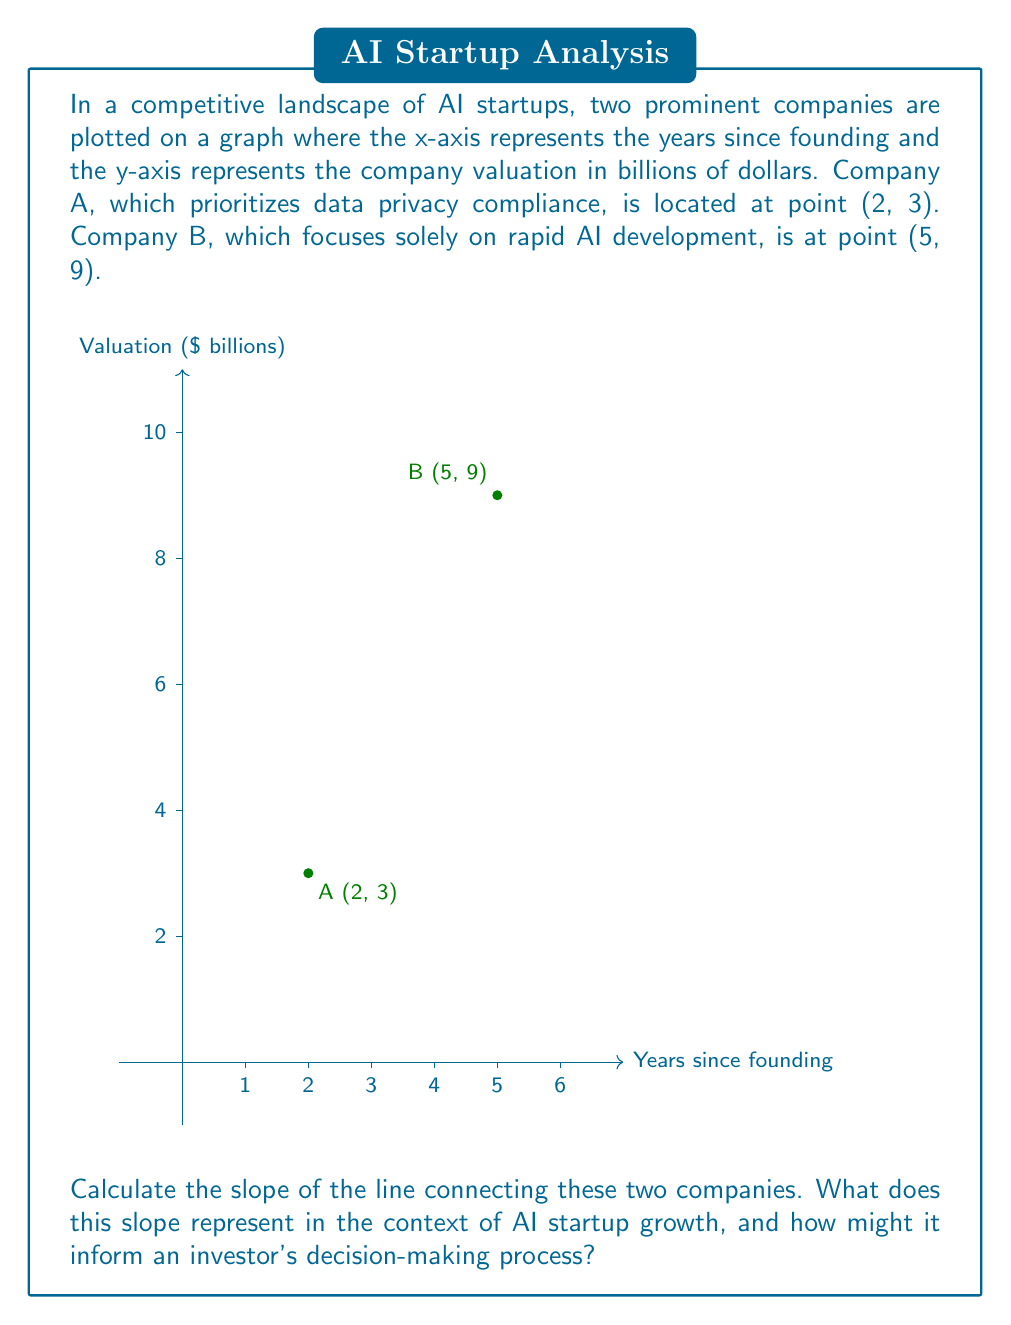Can you solve this math problem? To solve this problem, we'll follow these steps:

1) Recall the slope formula:
   $$ m = \frac{y_2 - y_1}{x_2 - x_1} $$
   where $(x_1, y_1)$ and $(x_2, y_2)$ are two points on the line.

2) Identify the coordinates:
   Company A: $(x_1, y_1) = (2, 3)$
   Company B: $(x_2, y_2) = (5, 9)$

3) Plug these values into the slope formula:
   $$ m = \frac{9 - 3}{5 - 2} = \frac{6}{3} = 2 $$

4) Interpret the result:
   The slope of 2 means that for each year that passes (x-axis), the company valuation increases by $2 billion on average.

5) Context for investors:
   This slope represents the average growth rate of these AI startups. A higher slope indicates faster growth. However, an investor should consider that:
   a) Company B's faster growth might come at the cost of potential future data privacy issues.
   b) Company A's slower but steady growth, prioritizing compliance, might be more sustainable long-term.
   c) The linear model assumes constant growth, which may not hold in reality.

6) Decision-making implications:
   An investor should weigh the rapid growth against potential risks associated with non-compliance. The choice between these companies would depend on the investor's risk tolerance and belief in the long-term importance of data privacy compliance in the AI sector.
Answer: Slope = 2; represents $2 billion increase in valuation per year on average. 